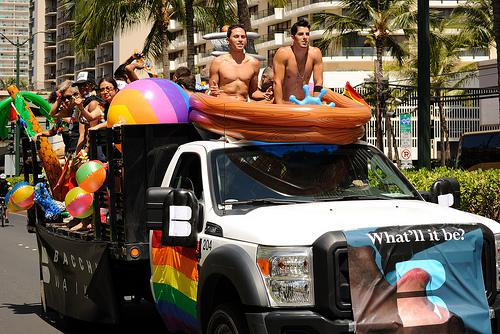Question: what are the guys on top of the truck sitting in?
Choices:
A. Lawn chairs.
B. A box.
C. A kids' swimming pool.
D. Mud.
Answer with the letter. Answer: C Question: what does the sign on the front of the truck say?
Choices:
A. Mack.
B. "What'll it be?".
C. U-Haul.
D. Work truck, do not follow.
Answer with the letter. Answer: B 